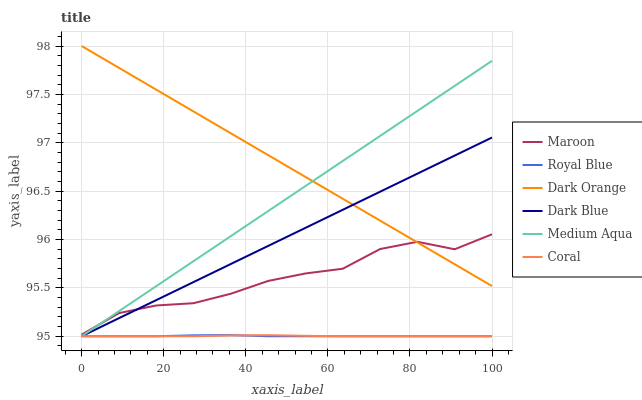Does Royal Blue have the minimum area under the curve?
Answer yes or no. Yes. Does Dark Orange have the maximum area under the curve?
Answer yes or no. Yes. Does Dark Blue have the minimum area under the curve?
Answer yes or no. No. Does Dark Blue have the maximum area under the curve?
Answer yes or no. No. Is Dark Orange the smoothest?
Answer yes or no. Yes. Is Maroon the roughest?
Answer yes or no. Yes. Is Dark Blue the smoothest?
Answer yes or no. No. Is Dark Blue the roughest?
Answer yes or no. No. Does Dark Blue have the lowest value?
Answer yes or no. Yes. Does Maroon have the lowest value?
Answer yes or no. No. Does Dark Orange have the highest value?
Answer yes or no. Yes. Does Dark Blue have the highest value?
Answer yes or no. No. Is Coral less than Dark Orange?
Answer yes or no. Yes. Is Maroon greater than Coral?
Answer yes or no. Yes. Does Dark Orange intersect Dark Blue?
Answer yes or no. Yes. Is Dark Orange less than Dark Blue?
Answer yes or no. No. Is Dark Orange greater than Dark Blue?
Answer yes or no. No. Does Coral intersect Dark Orange?
Answer yes or no. No. 